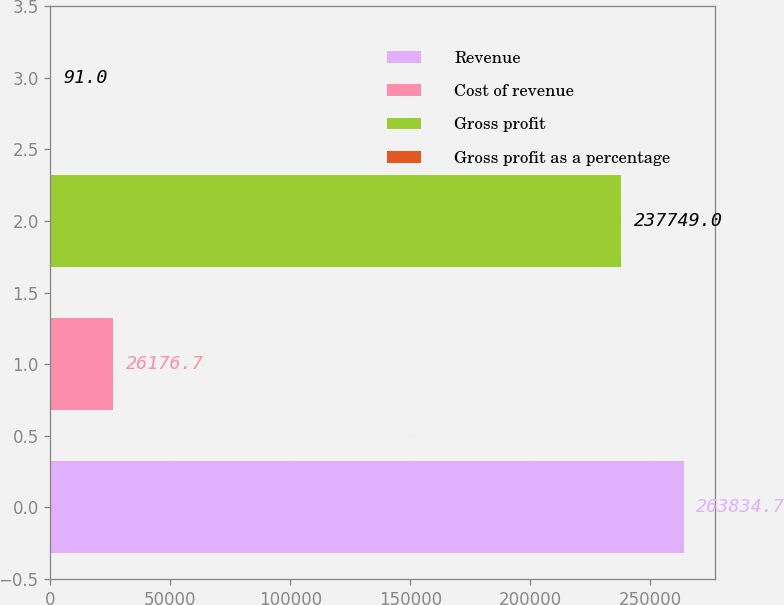Convert chart. <chart><loc_0><loc_0><loc_500><loc_500><bar_chart><fcel>Revenue<fcel>Cost of revenue<fcel>Gross profit<fcel>Gross profit as a percentage<nl><fcel>263835<fcel>26176.7<fcel>237749<fcel>91<nl></chart> 